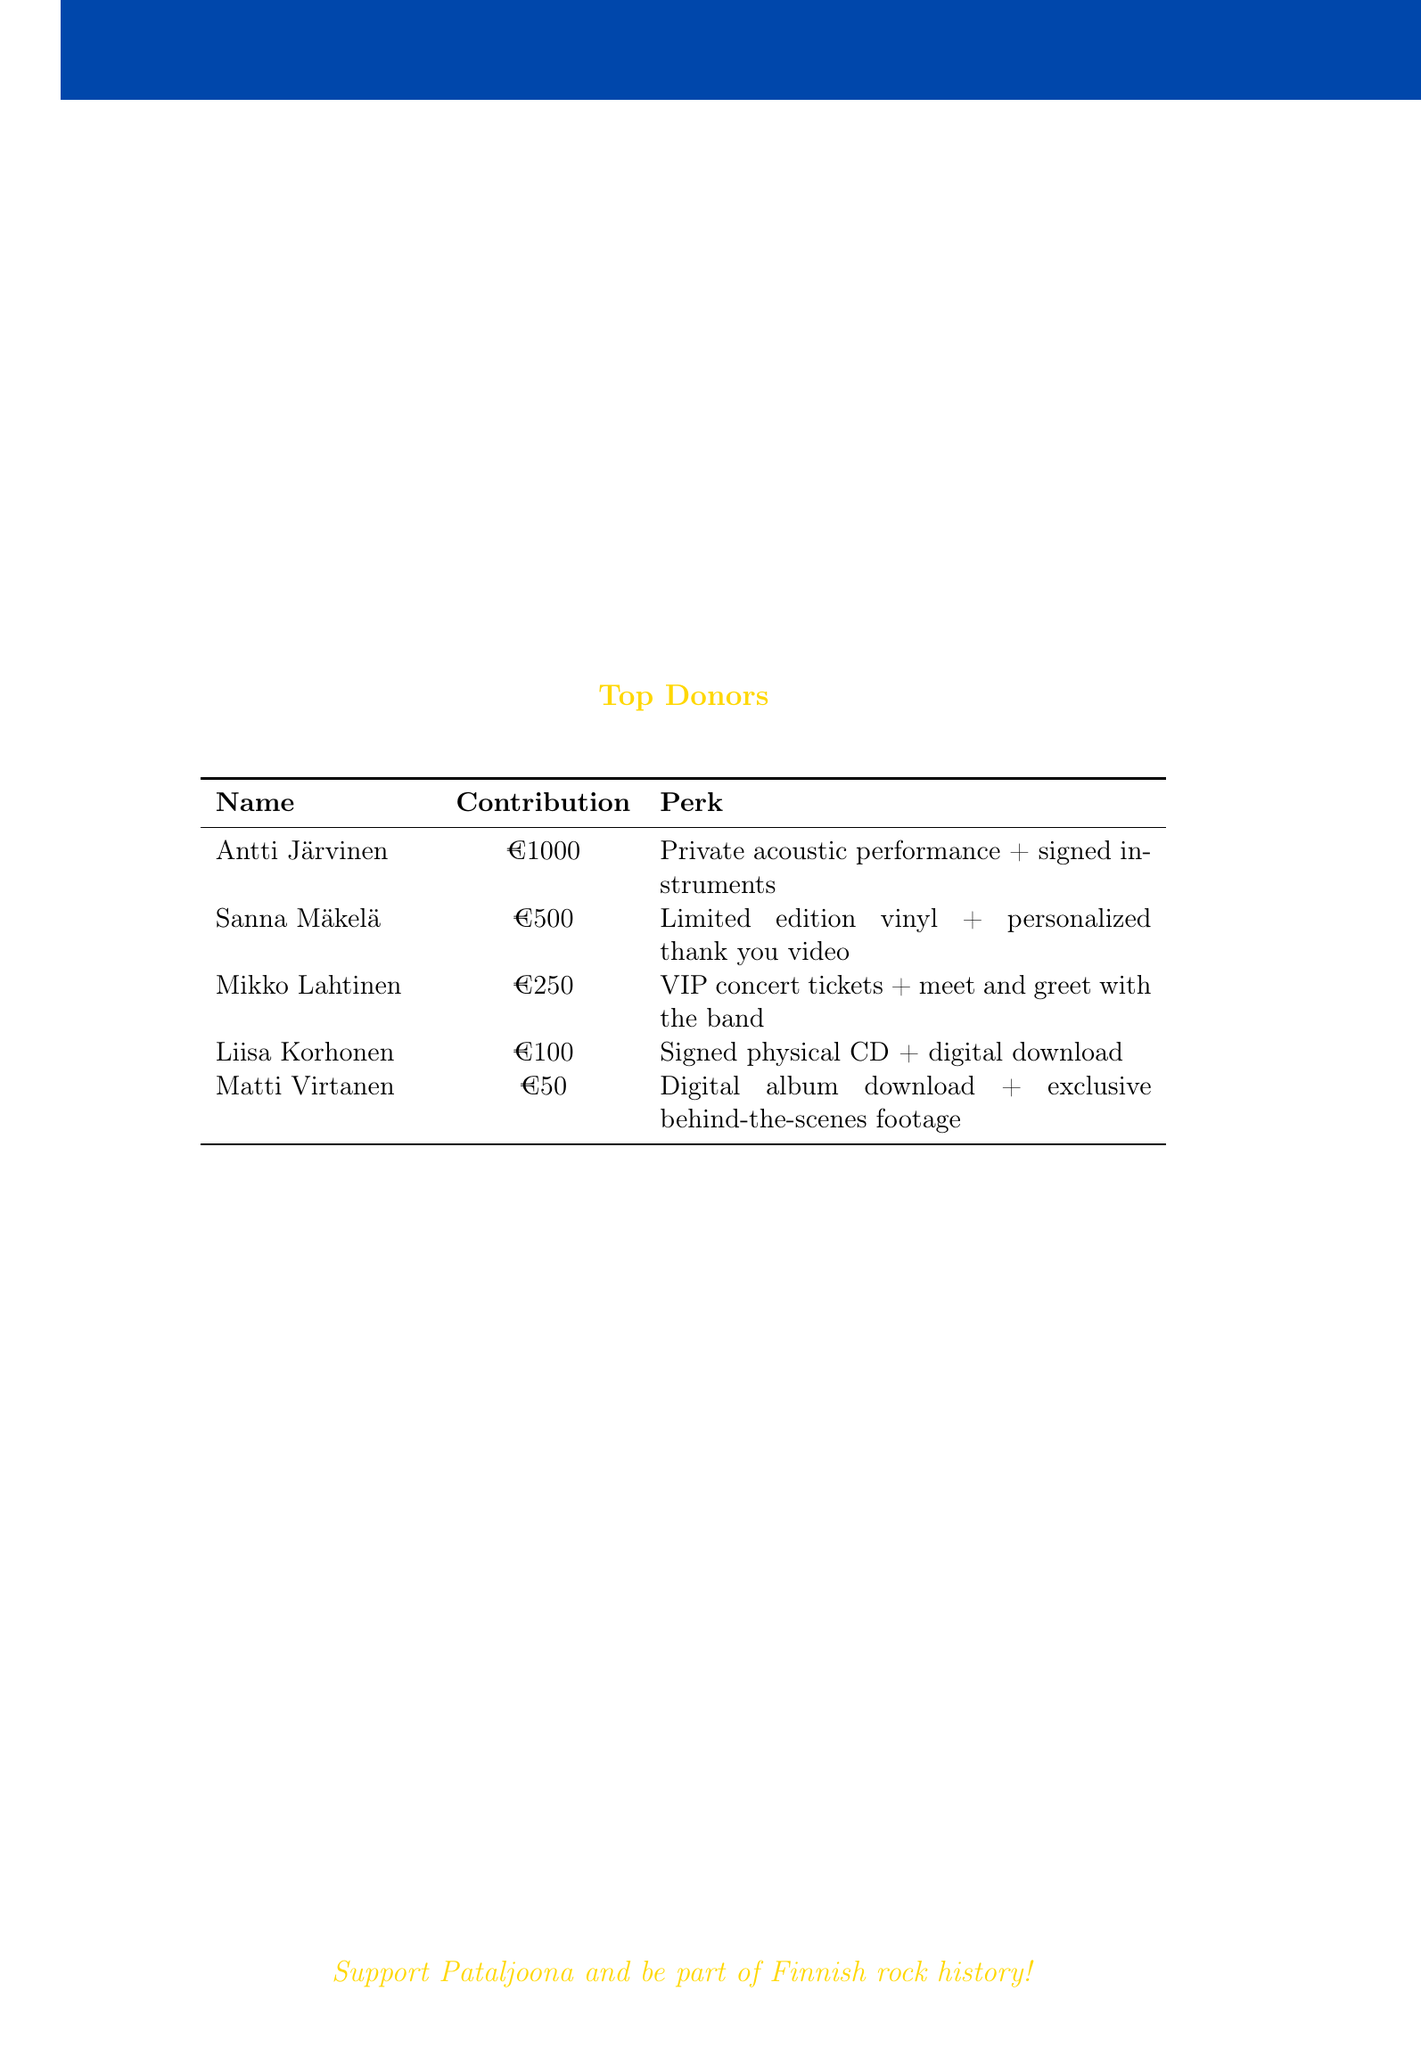What is the campaign goal? The campaign goal is explicitly stated in the document as €15,000.
Answer: €15,000 Who is the producer of the album? The document lists Hiili Hiilesmaa as the producer of the album.
Answer: Hiili Hiilesmaa How much has been raised so far? The total amount raised is mentioned as €12,750.
Answer: €12,750 What perk do donors receive for a contribution of €500? The document states that the perk for this contribution is a limited edition vinyl and a personalized thank you video.
Answer: Limited edition vinyl + personalized thank you video What is the expected release date of the album? The expected release date of the album is mentioned in the document as November 2023.
Answer: November 2023 How many tracks will the album have? The total number of tracks is stated as 12 in the album details section.
Answer: 12 What is the stretch goal for €25,000? The document describes the stretch goal for this amount as a music video for the lead single.
Answer: Music video for the lead single How many donors contributed to the campaign? The document states that the number of backers is 178.
Answer: 178 What new perk was added when the campaign reached halfway? The additional perk added at this point is exclusive Pataljoona t-shirts for €75 contributions.
Answer: Exclusive Pataljoona t-shirts for €75 contributions 